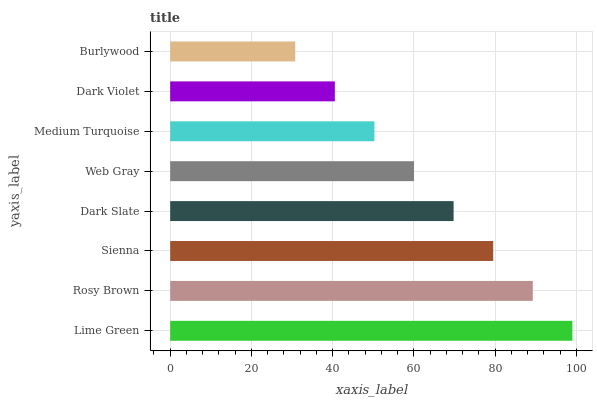Is Burlywood the minimum?
Answer yes or no. Yes. Is Lime Green the maximum?
Answer yes or no. Yes. Is Rosy Brown the minimum?
Answer yes or no. No. Is Rosy Brown the maximum?
Answer yes or no. No. Is Lime Green greater than Rosy Brown?
Answer yes or no. Yes. Is Rosy Brown less than Lime Green?
Answer yes or no. Yes. Is Rosy Brown greater than Lime Green?
Answer yes or no. No. Is Lime Green less than Rosy Brown?
Answer yes or no. No. Is Dark Slate the high median?
Answer yes or no. Yes. Is Web Gray the low median?
Answer yes or no. Yes. Is Burlywood the high median?
Answer yes or no. No. Is Dark Violet the low median?
Answer yes or no. No. 